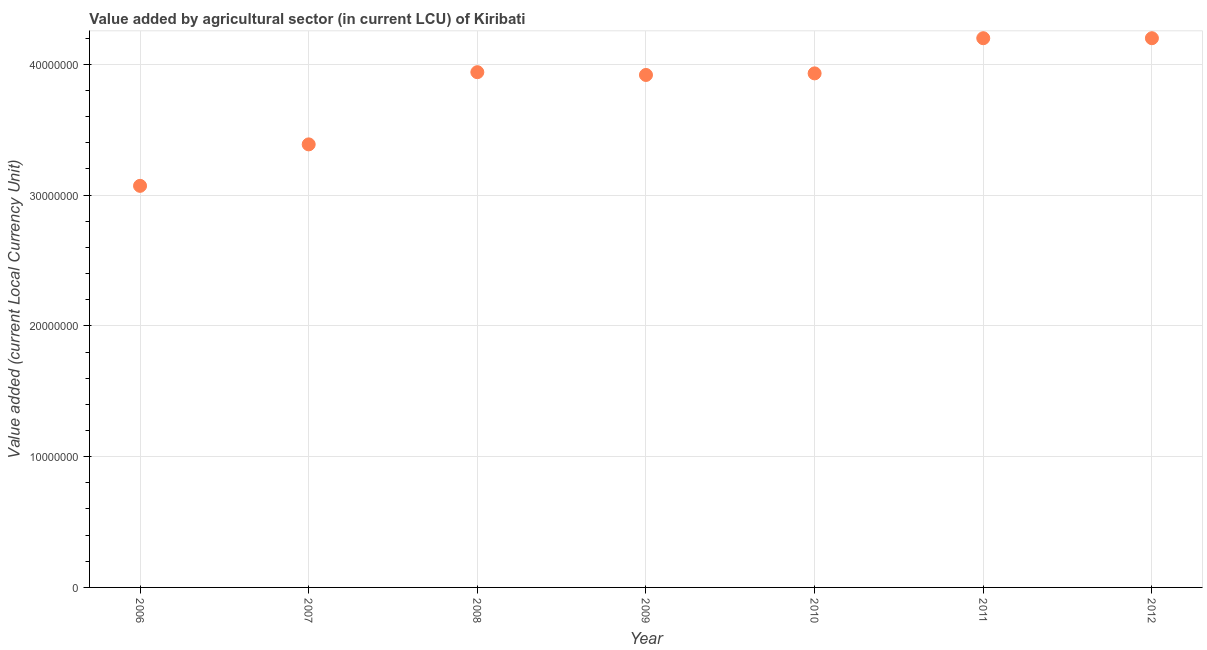What is the value added by agriculture sector in 2008?
Give a very brief answer. 3.94e+07. Across all years, what is the maximum value added by agriculture sector?
Your answer should be very brief. 4.20e+07. Across all years, what is the minimum value added by agriculture sector?
Offer a terse response. 3.07e+07. In which year was the value added by agriculture sector maximum?
Your answer should be very brief. 2011. In which year was the value added by agriculture sector minimum?
Give a very brief answer. 2006. What is the sum of the value added by agriculture sector?
Your response must be concise. 2.66e+08. What is the difference between the value added by agriculture sector in 2006 and 2011?
Make the answer very short. -1.13e+07. What is the average value added by agriculture sector per year?
Make the answer very short. 3.81e+07. What is the median value added by agriculture sector?
Your answer should be compact. 3.93e+07. In how many years, is the value added by agriculture sector greater than 22000000 LCU?
Provide a succinct answer. 7. What is the ratio of the value added by agriculture sector in 2010 to that in 2011?
Give a very brief answer. 0.94. Is the value added by agriculture sector in 2009 less than that in 2012?
Keep it short and to the point. Yes. What is the difference between the highest and the lowest value added by agriculture sector?
Your answer should be compact. 1.13e+07. In how many years, is the value added by agriculture sector greater than the average value added by agriculture sector taken over all years?
Your answer should be compact. 5. Does the value added by agriculture sector monotonically increase over the years?
Make the answer very short. No. How many dotlines are there?
Offer a very short reply. 1. How many years are there in the graph?
Offer a very short reply. 7. Does the graph contain any zero values?
Make the answer very short. No. What is the title of the graph?
Give a very brief answer. Value added by agricultural sector (in current LCU) of Kiribati. What is the label or title of the Y-axis?
Provide a succinct answer. Value added (current Local Currency Unit). What is the Value added (current Local Currency Unit) in 2006?
Your answer should be very brief. 3.07e+07. What is the Value added (current Local Currency Unit) in 2007?
Your answer should be compact. 3.39e+07. What is the Value added (current Local Currency Unit) in 2008?
Offer a terse response. 3.94e+07. What is the Value added (current Local Currency Unit) in 2009?
Provide a short and direct response. 3.92e+07. What is the Value added (current Local Currency Unit) in 2010?
Ensure brevity in your answer.  3.93e+07. What is the Value added (current Local Currency Unit) in 2011?
Ensure brevity in your answer.  4.20e+07. What is the Value added (current Local Currency Unit) in 2012?
Your answer should be compact. 4.20e+07. What is the difference between the Value added (current Local Currency Unit) in 2006 and 2007?
Keep it short and to the point. -3.17e+06. What is the difference between the Value added (current Local Currency Unit) in 2006 and 2008?
Offer a very short reply. -8.69e+06. What is the difference between the Value added (current Local Currency Unit) in 2006 and 2009?
Keep it short and to the point. -8.48e+06. What is the difference between the Value added (current Local Currency Unit) in 2006 and 2010?
Provide a succinct answer. -8.60e+06. What is the difference between the Value added (current Local Currency Unit) in 2006 and 2011?
Give a very brief answer. -1.13e+07. What is the difference between the Value added (current Local Currency Unit) in 2006 and 2012?
Offer a very short reply. -1.13e+07. What is the difference between the Value added (current Local Currency Unit) in 2007 and 2008?
Provide a short and direct response. -5.52e+06. What is the difference between the Value added (current Local Currency Unit) in 2007 and 2009?
Provide a short and direct response. -5.31e+06. What is the difference between the Value added (current Local Currency Unit) in 2007 and 2010?
Offer a very short reply. -5.43e+06. What is the difference between the Value added (current Local Currency Unit) in 2007 and 2011?
Keep it short and to the point. -8.12e+06. What is the difference between the Value added (current Local Currency Unit) in 2007 and 2012?
Offer a very short reply. -8.12e+06. What is the difference between the Value added (current Local Currency Unit) in 2008 and 2009?
Offer a very short reply. 2.12e+05. What is the difference between the Value added (current Local Currency Unit) in 2008 and 2010?
Provide a succinct answer. 9.19e+04. What is the difference between the Value added (current Local Currency Unit) in 2008 and 2011?
Offer a very short reply. -2.60e+06. What is the difference between the Value added (current Local Currency Unit) in 2008 and 2012?
Offer a very short reply. -2.60e+06. What is the difference between the Value added (current Local Currency Unit) in 2009 and 2010?
Give a very brief answer. -1.20e+05. What is the difference between the Value added (current Local Currency Unit) in 2009 and 2011?
Offer a terse response. -2.81e+06. What is the difference between the Value added (current Local Currency Unit) in 2009 and 2012?
Your answer should be compact. -2.81e+06. What is the difference between the Value added (current Local Currency Unit) in 2010 and 2011?
Give a very brief answer. -2.69e+06. What is the difference between the Value added (current Local Currency Unit) in 2010 and 2012?
Offer a terse response. -2.69e+06. What is the difference between the Value added (current Local Currency Unit) in 2011 and 2012?
Provide a succinct answer. 0. What is the ratio of the Value added (current Local Currency Unit) in 2006 to that in 2007?
Ensure brevity in your answer.  0.91. What is the ratio of the Value added (current Local Currency Unit) in 2006 to that in 2008?
Make the answer very short. 0.78. What is the ratio of the Value added (current Local Currency Unit) in 2006 to that in 2009?
Provide a succinct answer. 0.78. What is the ratio of the Value added (current Local Currency Unit) in 2006 to that in 2010?
Your answer should be compact. 0.78. What is the ratio of the Value added (current Local Currency Unit) in 2006 to that in 2011?
Make the answer very short. 0.73. What is the ratio of the Value added (current Local Currency Unit) in 2006 to that in 2012?
Make the answer very short. 0.73. What is the ratio of the Value added (current Local Currency Unit) in 2007 to that in 2008?
Give a very brief answer. 0.86. What is the ratio of the Value added (current Local Currency Unit) in 2007 to that in 2009?
Provide a short and direct response. 0.86. What is the ratio of the Value added (current Local Currency Unit) in 2007 to that in 2010?
Your answer should be compact. 0.86. What is the ratio of the Value added (current Local Currency Unit) in 2007 to that in 2011?
Offer a terse response. 0.81. What is the ratio of the Value added (current Local Currency Unit) in 2007 to that in 2012?
Keep it short and to the point. 0.81. What is the ratio of the Value added (current Local Currency Unit) in 2008 to that in 2011?
Provide a short and direct response. 0.94. What is the ratio of the Value added (current Local Currency Unit) in 2008 to that in 2012?
Make the answer very short. 0.94. What is the ratio of the Value added (current Local Currency Unit) in 2009 to that in 2011?
Ensure brevity in your answer.  0.93. What is the ratio of the Value added (current Local Currency Unit) in 2009 to that in 2012?
Make the answer very short. 0.93. What is the ratio of the Value added (current Local Currency Unit) in 2010 to that in 2011?
Your answer should be compact. 0.94. What is the ratio of the Value added (current Local Currency Unit) in 2010 to that in 2012?
Offer a very short reply. 0.94. 